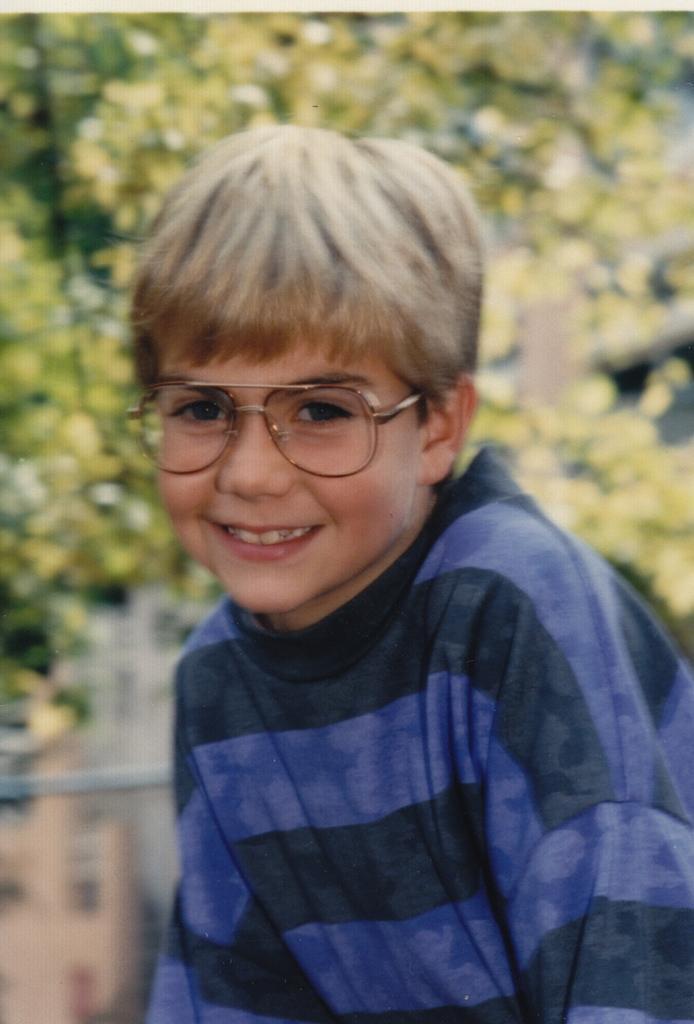In one or two sentences, can you explain what this image depicts? In this Image I can see a person wearing blue color dress and smiling. Back I can see trees and blurred background. 